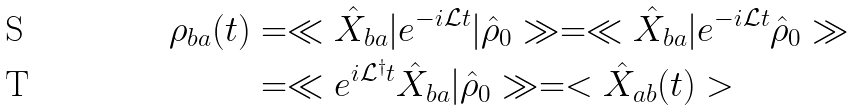<formula> <loc_0><loc_0><loc_500><loc_500>\rho _ { b a } ( t ) & = \ll \hat { X } _ { b a } | e ^ { - i \mathcal { L } t } | \hat { \rho } _ { 0 } \gg = \ll \hat { X } _ { b a } | e ^ { - i \mathcal { L } t } \hat { \rho } _ { 0 } \gg \\ & = \ll e ^ { i \mathcal { L } ^ { \dagger } t } \hat { X } _ { b a } | \hat { \rho } _ { 0 } \gg = < \hat { X } _ { a b } ( t ) ></formula> 